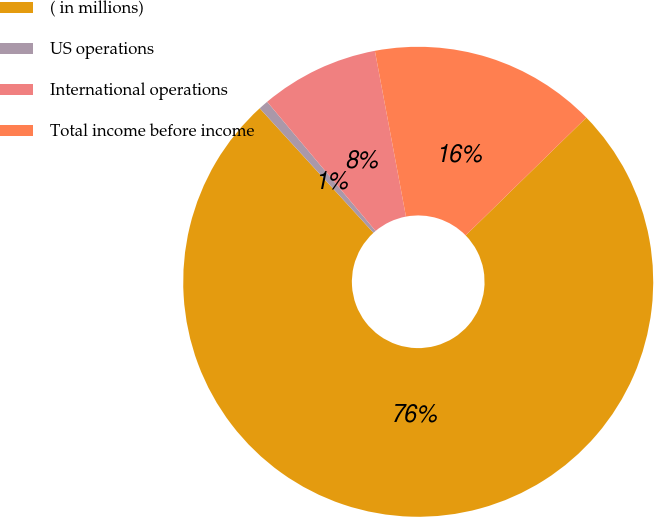Convert chart. <chart><loc_0><loc_0><loc_500><loc_500><pie_chart><fcel>( in millions)<fcel>US operations<fcel>International operations<fcel>Total income before income<nl><fcel>75.53%<fcel>0.67%<fcel>8.16%<fcel>15.64%<nl></chart> 